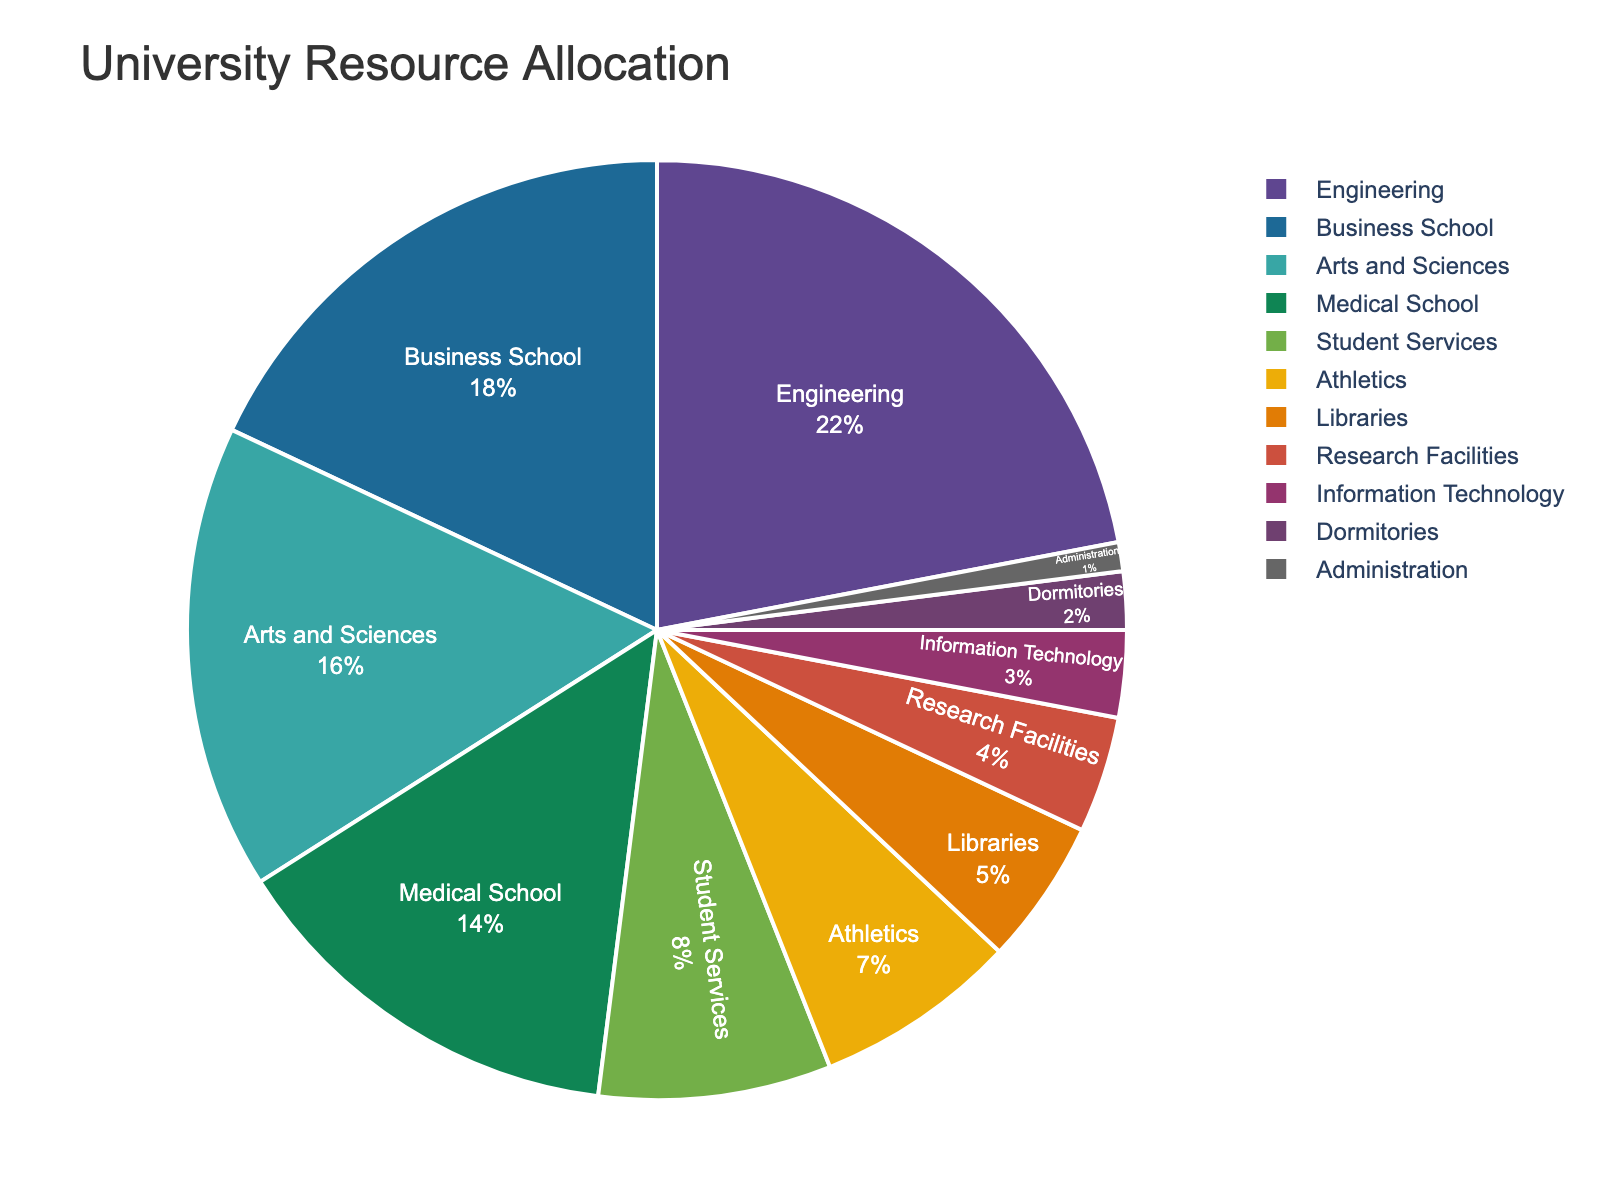What percentage of the total resources is allocated to the Medical School and Libraries combined? Add the percentages for the Medical School (14%) and Libraries (5%). The sum is 14+5 = 19%.
Answer: 19% Which department receives more resources: Business School or Arts and Sciences? Compare the percentages: Business School (18%) and Arts and Sciences (16%). The Business School receives more resources.
Answer: Business School By how much does the allocation for Research Facilities differ from the allocation for Administration? Subtract the percentage of Administration (1%) from Research Facilities (4%). The difference is 4-1 = 3%.
Answer: 3% Which departments have a smaller allocation than Athletics? Identify all departments with a percentage less than Athletics (7%): Libraries (5%), Research Facilities (4%), Information Technology (3%), Dormitories (2%), and Administration (1%). List these departments.
Answer: Libraries, Research Facilities, Information Technology, Dormitories, Administration What is the combined allocation percentage for Student Services and IT? Add the percentages for Student Services (8%) and Information Technology (3%). The sum is 8+3 = 11%.
Answer: 11% Order the top three departments by resource allocation. List the departments in descending order of their allocation: 1) Engineering (22%), 2) Business School (18%), 3) Arts and Sciences (16%).
Answer: Engineering, Business School, Arts and Sciences Does the sum of resources allocated to Athletics and Dormitories equal the resouce allocation for Arts and Sciences? Add percentages for Athletics (7%) and Dormitories (2%). Compare the sum (7+2 = 9%) with Arts and Sciences (16%). They do not equal.
Answer: No What is the total percentage allocated to departments and facilities excluding the top three departments? Subtract the sum of the top three department percentages (22% + 18% + 16%) from 100%. The calculation is 100 - (22+18+16) = 44%. Therefore, 44% is allocated to categories other than the top three.
Answer: 44% Which section is represented by the smallest slice in the pie chart? Identify the department with the smallest percentage in the chart: Administration (1%).
Answer: Administration 